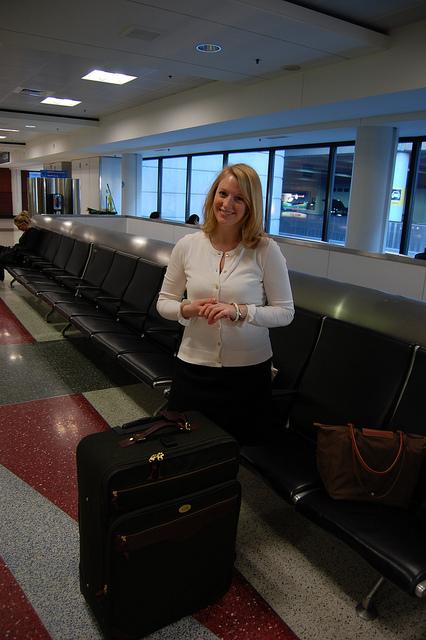What's in the bag in front of her?
Concise answer only. Luggage. How many bags does this woman have?
Answer briefly. 2. Where is this woman?
Short answer required. Airport. 